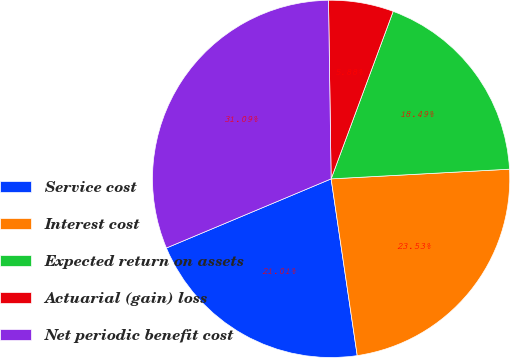Convert chart. <chart><loc_0><loc_0><loc_500><loc_500><pie_chart><fcel>Service cost<fcel>Interest cost<fcel>Expected return on assets<fcel>Actuarial (gain) loss<fcel>Net periodic benefit cost<nl><fcel>21.01%<fcel>23.53%<fcel>18.49%<fcel>5.88%<fcel>31.09%<nl></chart> 